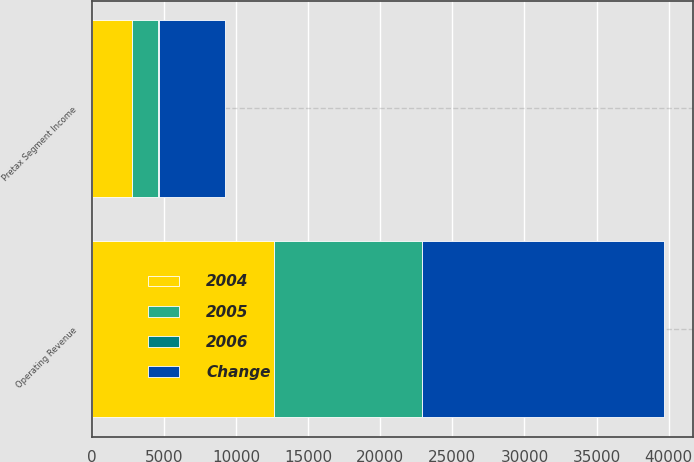Convert chart to OTSL. <chart><loc_0><loc_0><loc_500><loc_500><stacked_bar_chart><ecel><fcel>Operating Revenue<fcel>Pretax Segment Income<nl><fcel>Change<fcel>16767<fcel>4603<nl><fcel>2004<fcel>12648<fcel>2805<nl><fcel>2006<fcel>33<fcel>64<nl><fcel>2005<fcel>10239<fcel>1801<nl></chart> 